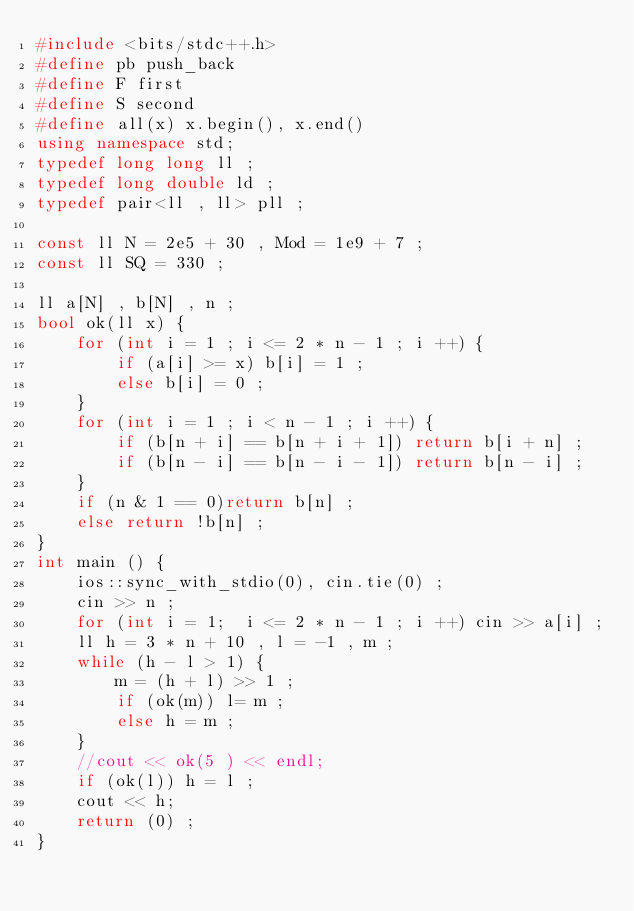<code> <loc_0><loc_0><loc_500><loc_500><_C++_>#include <bits/stdc++.h>
#define pb push_back
#define F first
#define S second
#define all(x) x.begin(), x.end()
using namespace std;
typedef long long ll ; 
typedef long double ld ;
typedef pair<ll , ll> pll ;

const ll N = 2e5 + 30 , Mod = 1e9 + 7 ;
const ll SQ = 330 ;

ll a[N] , b[N] , n ;
bool ok(ll x) {
	for (int i = 1 ; i <= 2 * n - 1 ; i ++) {
		if (a[i] >= x) b[i] = 1 ;
		else b[i] = 0 ;
	}
	for (int i = 1 ; i < n - 1 ; i ++) {
		if (b[n + i] == b[n + i + 1]) return b[i + n] ;
		if (b[n - i] == b[n - i - 1]) return b[n - i] ;
	}
	if (n & 1 == 0)return b[n] ;
	else return !b[n] ;
}
int main () {
    ios::sync_with_stdio(0), cin.tie(0) ;
    cin >> n ;
    for (int i = 1;  i <= 2 * n - 1 ; i ++) cin >> a[i] ;
    ll h = 3 * n + 10 , l = -1 , m ;
    while (h - l > 1) {
    	m = (h + l) >> 1 ;
    	if (ok(m)) l= m ;
    	else h = m ;
	}
	//cout << ok(5 ) << endl;
	if (ok(l)) h = l ;
	cout << h; 
    return (0) ;
}</code> 